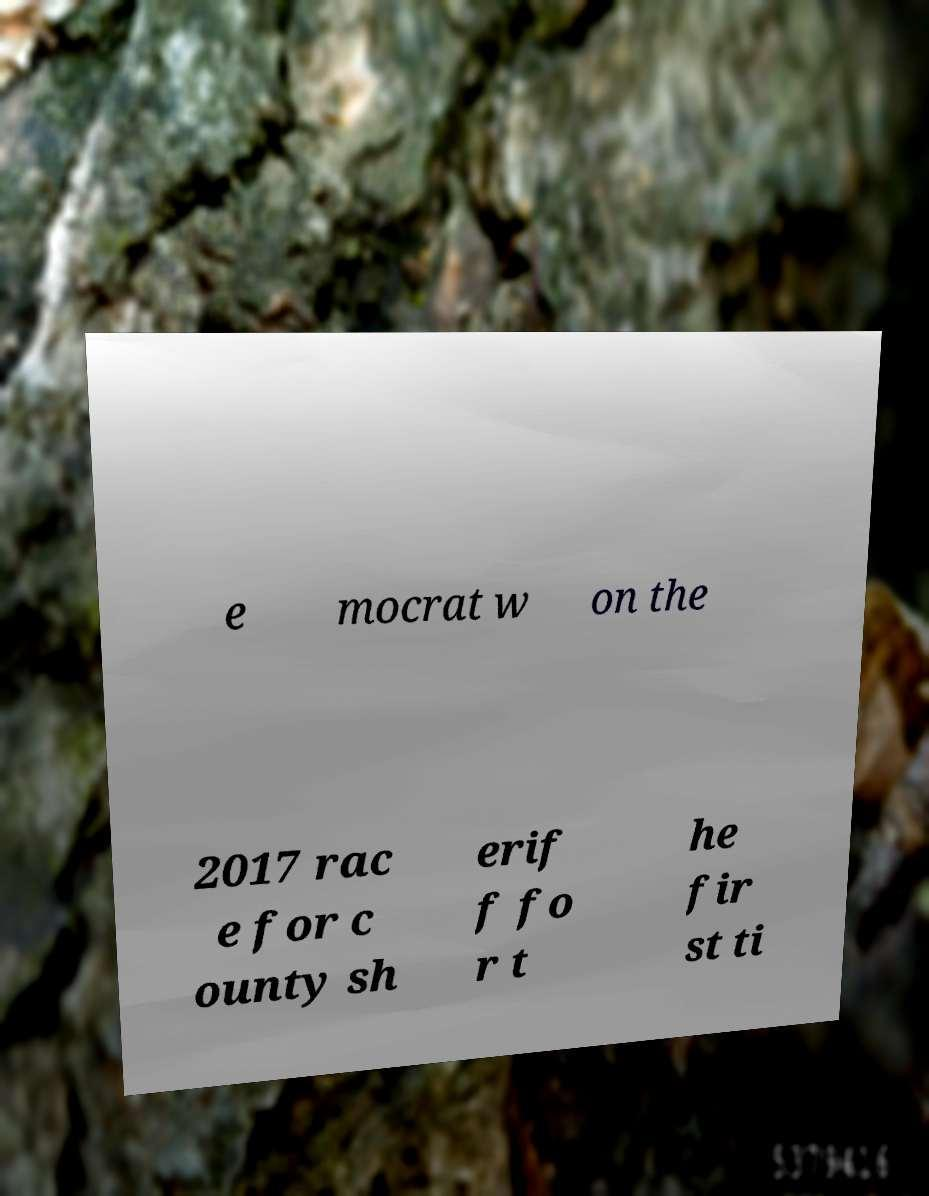Please identify and transcribe the text found in this image. e mocrat w on the 2017 rac e for c ounty sh erif f fo r t he fir st ti 